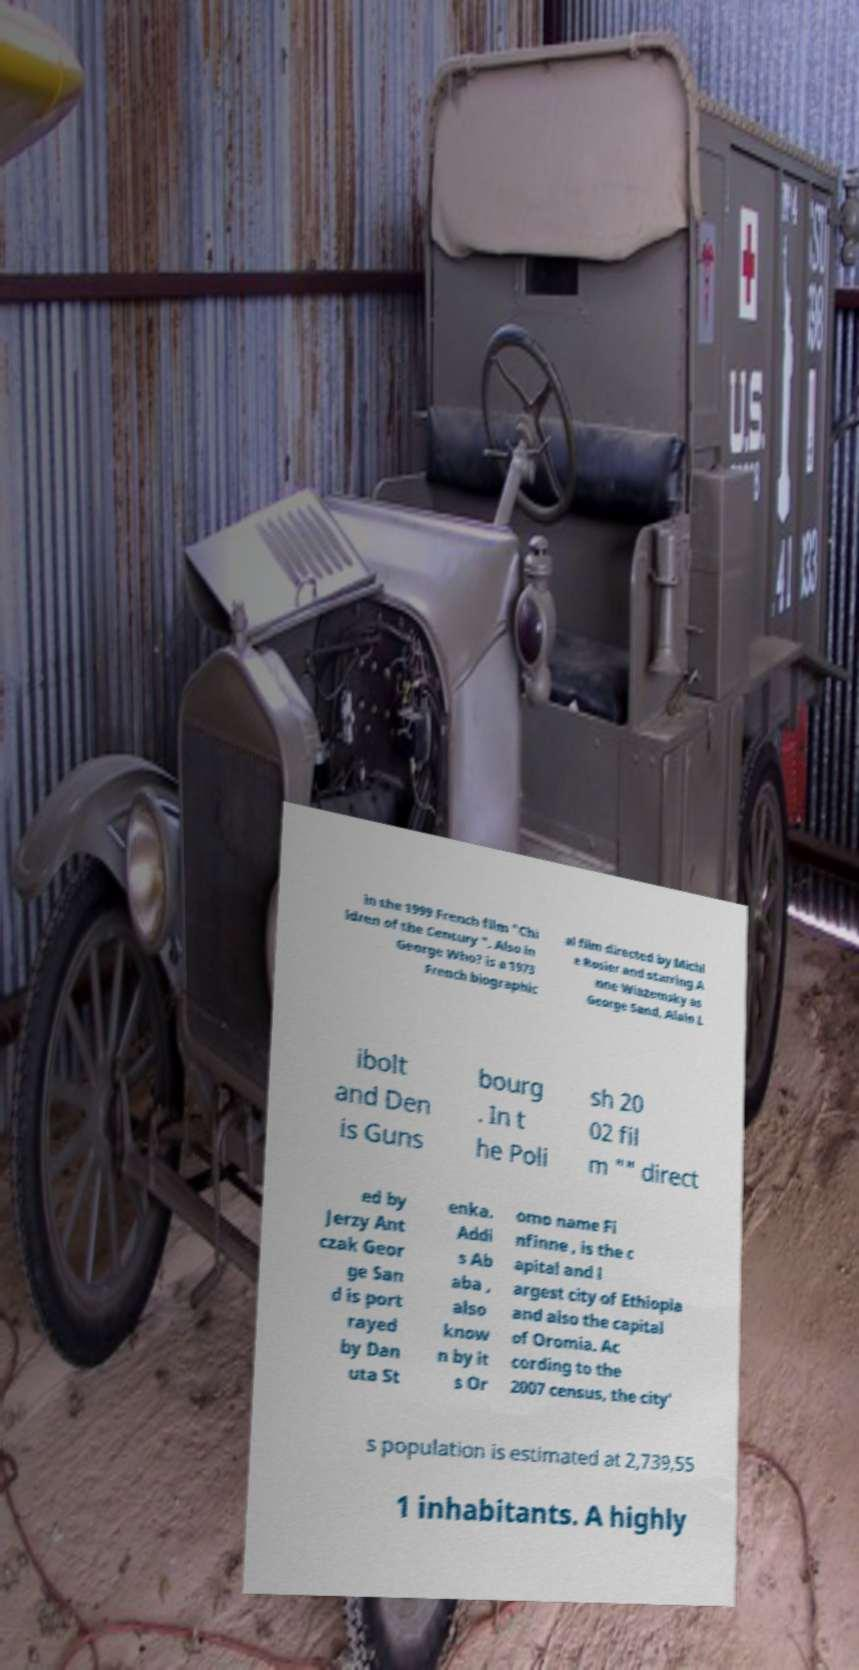Could you assist in decoding the text presented in this image and type it out clearly? in the 1999 French film "Chi ldren of the Century ". Also in George Who? is a 1973 French biographic al film directed by Michl e Rosier and starring A nne Wiazemsky as George Sand, Alain L ibolt and Den is Guns bourg . In t he Poli sh 20 02 fil m "" direct ed by Jerzy Ant czak Geor ge San d is port rayed by Dan uta St enka. Addi s Ab aba , also know n by it s Or omo name Fi nfinne , is the c apital and l argest city of Ethiopia and also the capital of Oromia. Ac cording to the 2007 census, the city' s population is estimated at 2,739,55 1 inhabitants. A highly 